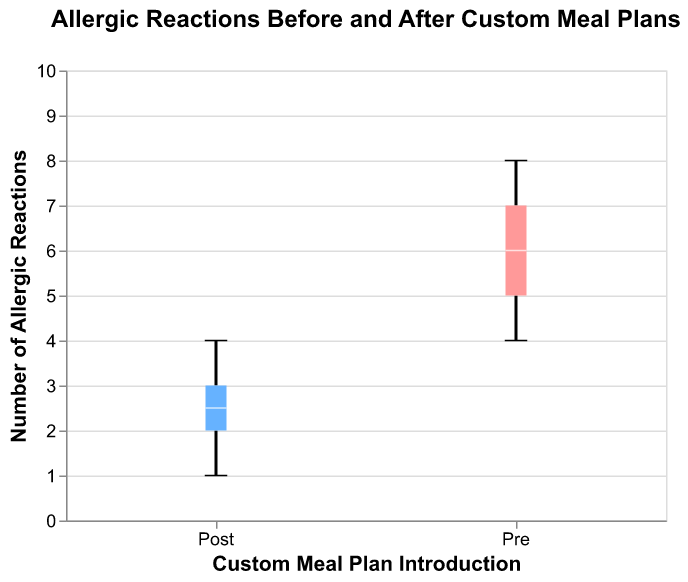How many groups are shown in the figure? The figure shows two groups, labeled "Pre" and "Post" on the x-axis.
Answer: Two What is the title of the figure? The title can be found at the top of the figure, which reads, "Allergic Reactions Before and After Custom Meal Plans".
Answer: Allergic Reactions Before and After Custom Meal Plans What does the y-axis represent? The y-axis is labeled as "Number of Allergic Reactions," indicating the count of allergic reactions.
Answer: Number of Allergic Reactions Which group has a wider interquartile range (IQR)? By observing the box plots, one can compare the length of the boxes to determine the IQR. The "Pre" group has a wider interquartile range as its box is longer than that of the "Post" group.
Answer: Pre What is the median number of allergic reactions in the Post group? The median is represented by the line within the box of the box plot. In the "Post" group, the median line is positioned at 3.
Answer: 3 What is the range of the number of allergic reactions in the Pre group? The range is determined by the minimum and maximum values represented by the whiskers. The minimum is 4 and maximum is 8 for the "Pre" group. Therefore, the range is 8 - 4 = 4.
Answer: 4 What is the difference between the median values of the Pre and Post groups? The median of the Pre group is at 6 and the median of the Post group is 3. Thus, the difference is 6 - 3 = 3.
Answer: 3 Which group has fewer outliers? Outliers are typically shown as individual points outside the whiskers. Since there are no outliers in either group, both groups have zero outliers.
Answer: Both have zero How did the custom meal plans affect the number of allergic reactions on average? By observing the positions of the median lines and the overall spread, it's clear that the "Post" group is generally lower than the "Pre" group, indicating a reduction in allergic reactions. The detailed comparison of median values (6 vs. 3) also confirms this.
Answer: Reduced Which group appears more consistent (less variability) in the number of allergic reactions? Variability is shown by the interquartile range (IQR); a shorter box indicates less variability. The "Post" group has a shorter box compared to the "Pre" group.
Answer: Post 